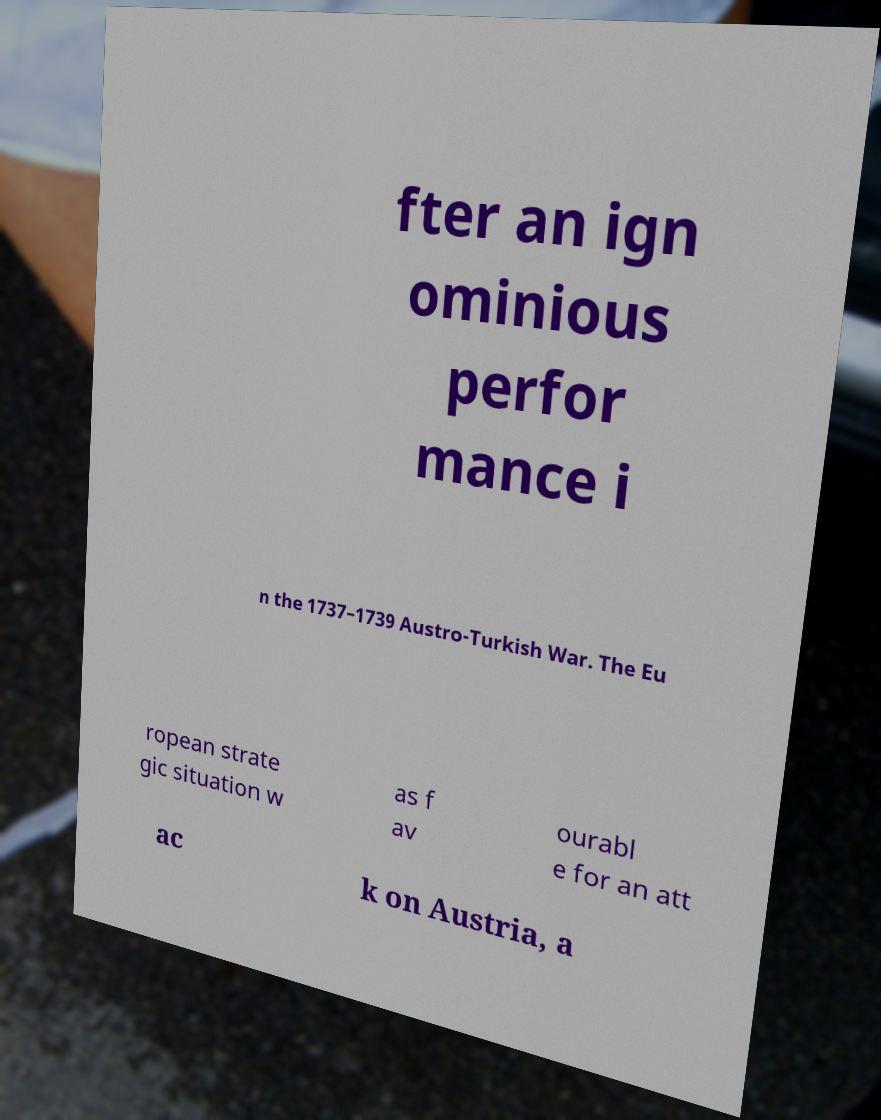Please identify and transcribe the text found in this image. fter an ign ominious perfor mance i n the 1737–1739 Austro-Turkish War. The Eu ropean strate gic situation w as f av ourabl e for an att ac k on Austria, a 